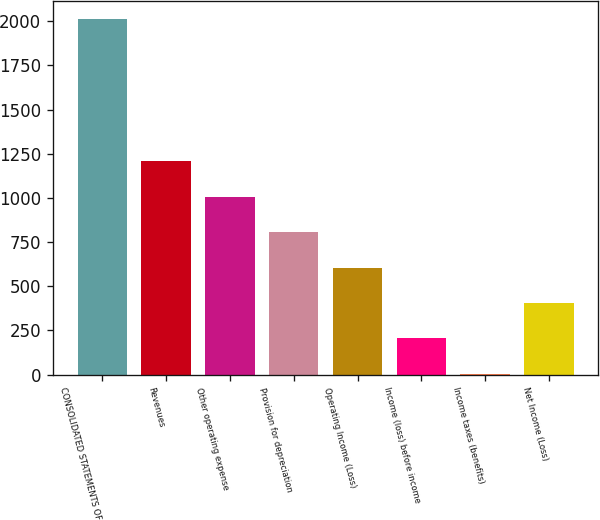Convert chart. <chart><loc_0><loc_0><loc_500><loc_500><bar_chart><fcel>CONSOLIDATED STATEMENTS OF<fcel>Revenues<fcel>Other operating expense<fcel>Provision for depreciation<fcel>Operating Income (Loss)<fcel>Income (loss) before income<fcel>Income taxes (benefits)<fcel>Net Income (Loss)<nl><fcel>2011<fcel>1208.2<fcel>1007.5<fcel>806.8<fcel>606.1<fcel>204.7<fcel>4<fcel>405.4<nl></chart> 